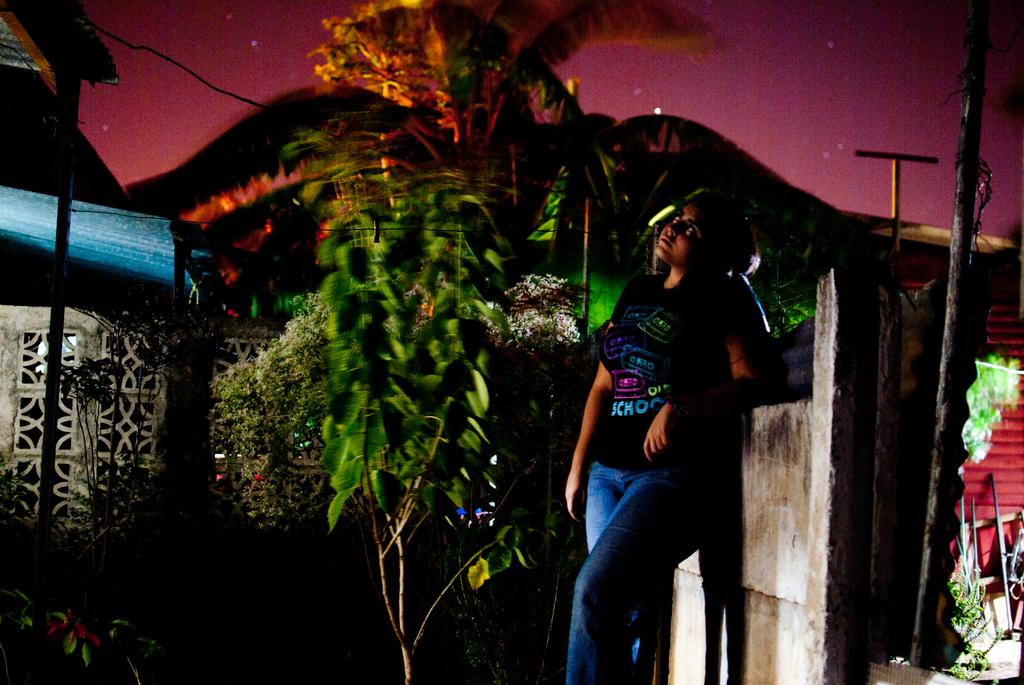Who is present in the image? There is a woman in the image. What type of vegetation can be seen in the image? There are plants, flowers, and trees in the image. What structures are visible in the image? There are poles in the image. What can be seen in the background of the image? The sky is visible in the background of the image. What type of flame can be seen in the image? There is no flame present in the image. How does the woman's brain appear in the image? The image does not show the woman's brain, so it cannot be described. --- Facts: 1. There is a car in the image. 2. The car is red. 3. There are people in the car. 4. The car has four wheels. 5. The car has a license plate. Absurd Topics: ocean, bird, mountain Conversation: What is the main subject of the image? The main subject of the image is a car. What color is the car? The car is red. Who is inside the car? There are people in the car. How many wheels does the car have? The car has four wheels. What is attached to the back of the car? The car has a license plate. Reasoning: Let's think step by step in order to produce the conversation. We start by identifying the main subject in the image, which is the car. Then, we expand the conversation to include other details about the car, such as its color, the presence of people inside, the number of wheels, and the license plate. Each question is designed to elicit a specific detail about the image that is known from the provided facts. Absurd Question/Answer: What type of ocean can be seen in the image? There is no ocean present in the image; it features a red car with people inside. Can you see any birds flying near the car in the image? There are no birds visible in the image. 